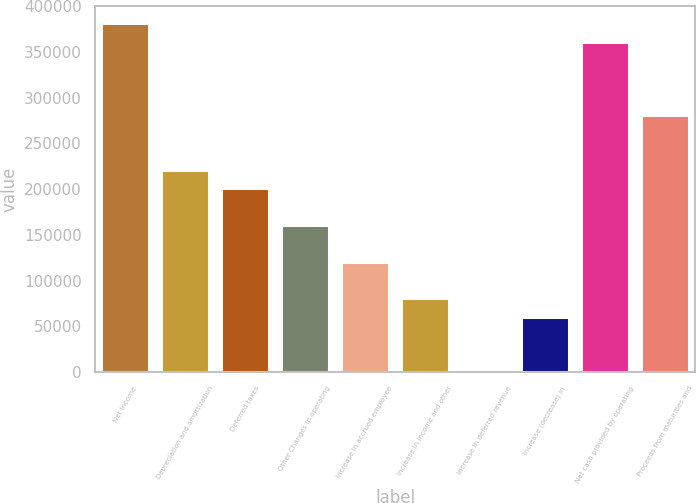Convert chart. <chart><loc_0><loc_0><loc_500><loc_500><bar_chart><fcel>Net income<fcel>Depreciation and amortization<fcel>Deferred taxes<fcel>Other Changes in operating<fcel>Increase in accrued employee<fcel>Increase in income and other<fcel>Increase in deferred revenue<fcel>Increase (decrease) in<fcel>Net cash provided by operating<fcel>Proceeds from maturities and<nl><fcel>381459<fcel>220930<fcel>200864<fcel>160732<fcel>120600<fcel>80467.4<fcel>203<fcel>60401.3<fcel>361393<fcel>281128<nl></chart> 